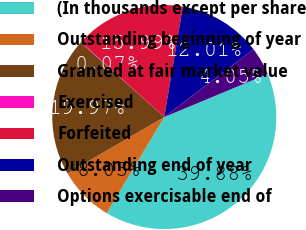<chart> <loc_0><loc_0><loc_500><loc_500><pie_chart><fcel>(In thousands except per share<fcel>Outstanding beginning of year<fcel>Granted at fair market value<fcel>Exercised<fcel>Forfeited<fcel>Outstanding end of year<fcel>Options exercisable end of<nl><fcel>39.88%<fcel>8.03%<fcel>19.97%<fcel>0.07%<fcel>15.99%<fcel>12.01%<fcel>4.05%<nl></chart> 